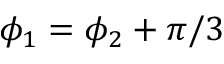<formula> <loc_0><loc_0><loc_500><loc_500>\phi _ { 1 } = \phi _ { 2 } + \pi / 3</formula> 